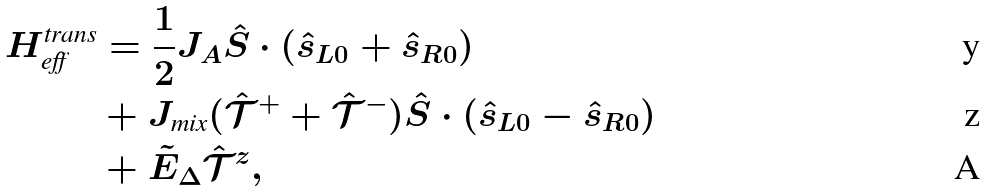Convert formula to latex. <formula><loc_0><loc_0><loc_500><loc_500>H _ { \text {eff} } ^ { \text {trans} } & = \frac { 1 } { 2 } J _ { A } \hat { S } \cdot ( \hat { s } _ { L 0 } + \hat { s } _ { R 0 } ) \\ & + J _ { \text {mix} } ( \hat { \mathcal { T } } ^ { + } + \hat { \mathcal { T } } ^ { - } ) \hat { S } \cdot ( \hat { s } _ { L 0 } - \hat { s } _ { R 0 } ) \\ & + \tilde { E } _ { \Delta } \hat { \mathcal { T } } ^ { z } ,</formula> 